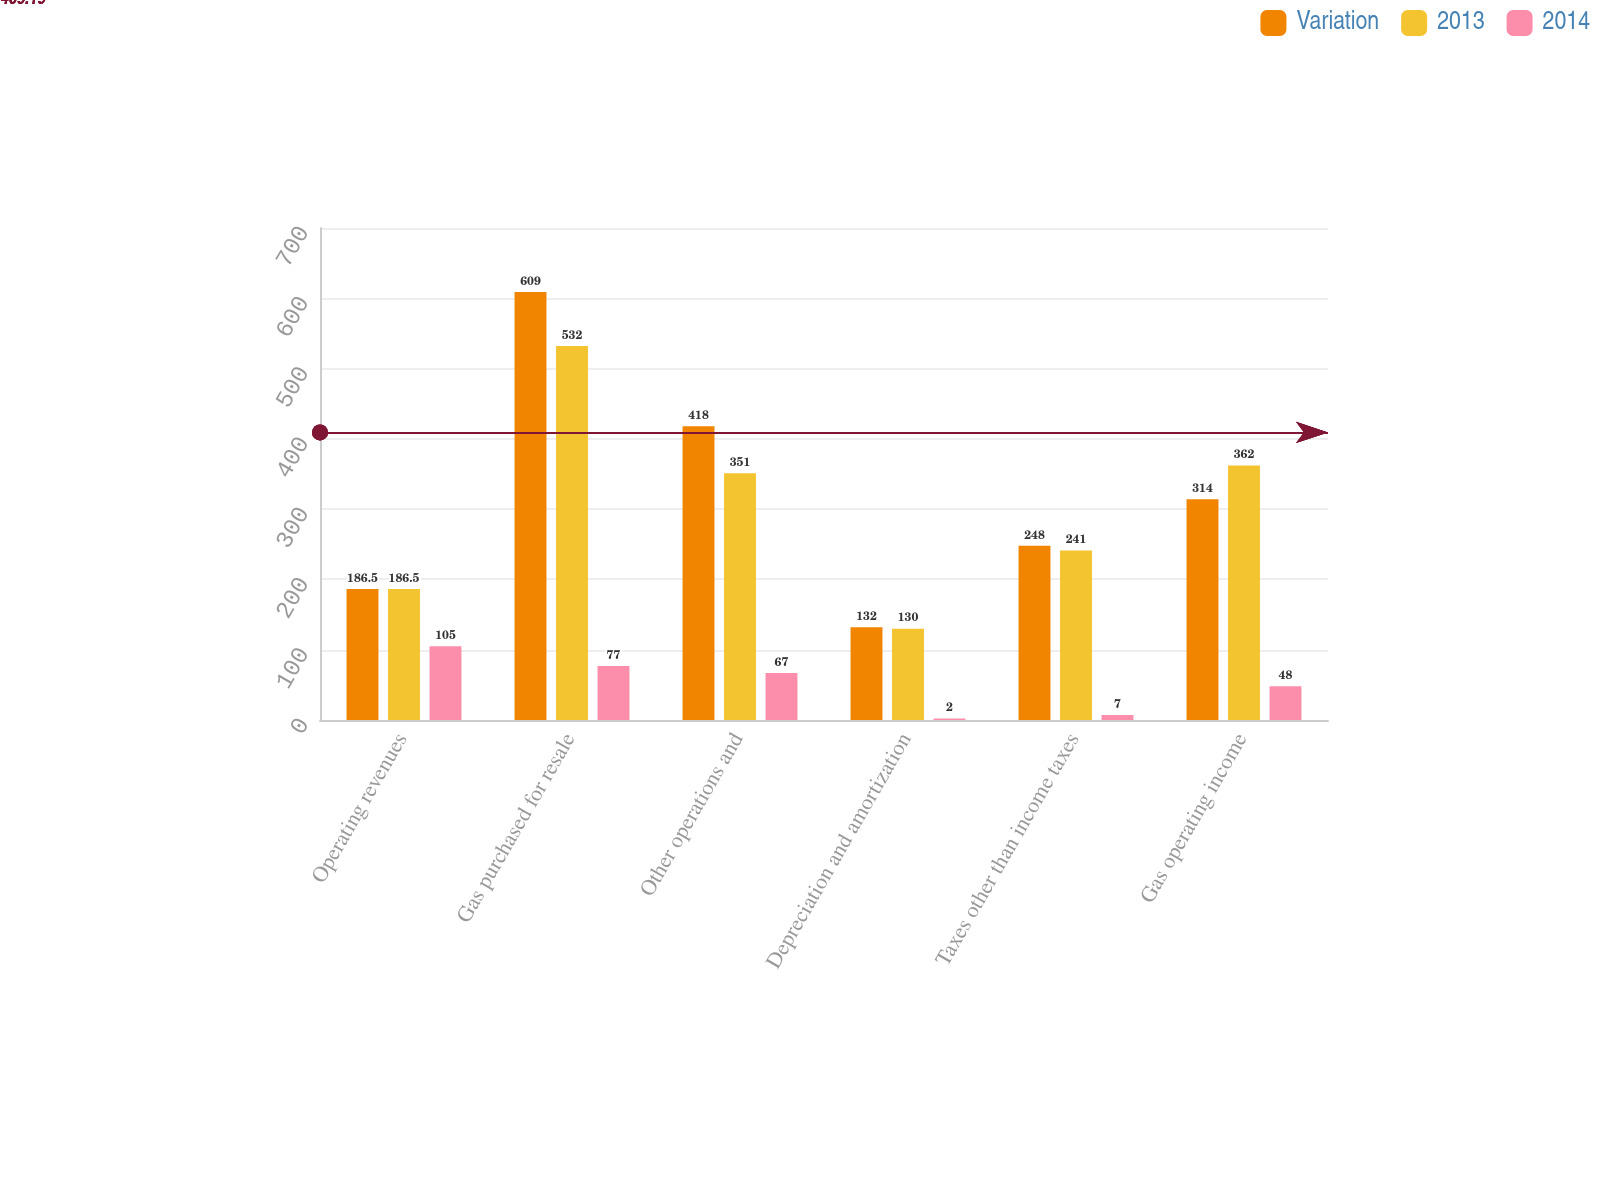Convert chart to OTSL. <chart><loc_0><loc_0><loc_500><loc_500><stacked_bar_chart><ecel><fcel>Operating revenues<fcel>Gas purchased for resale<fcel>Other operations and<fcel>Depreciation and amortization<fcel>Taxes other than income taxes<fcel>Gas operating income<nl><fcel>Variation<fcel>186.5<fcel>609<fcel>418<fcel>132<fcel>248<fcel>314<nl><fcel>2013<fcel>186.5<fcel>532<fcel>351<fcel>130<fcel>241<fcel>362<nl><fcel>2014<fcel>105<fcel>77<fcel>67<fcel>2<fcel>7<fcel>48<nl></chart> 